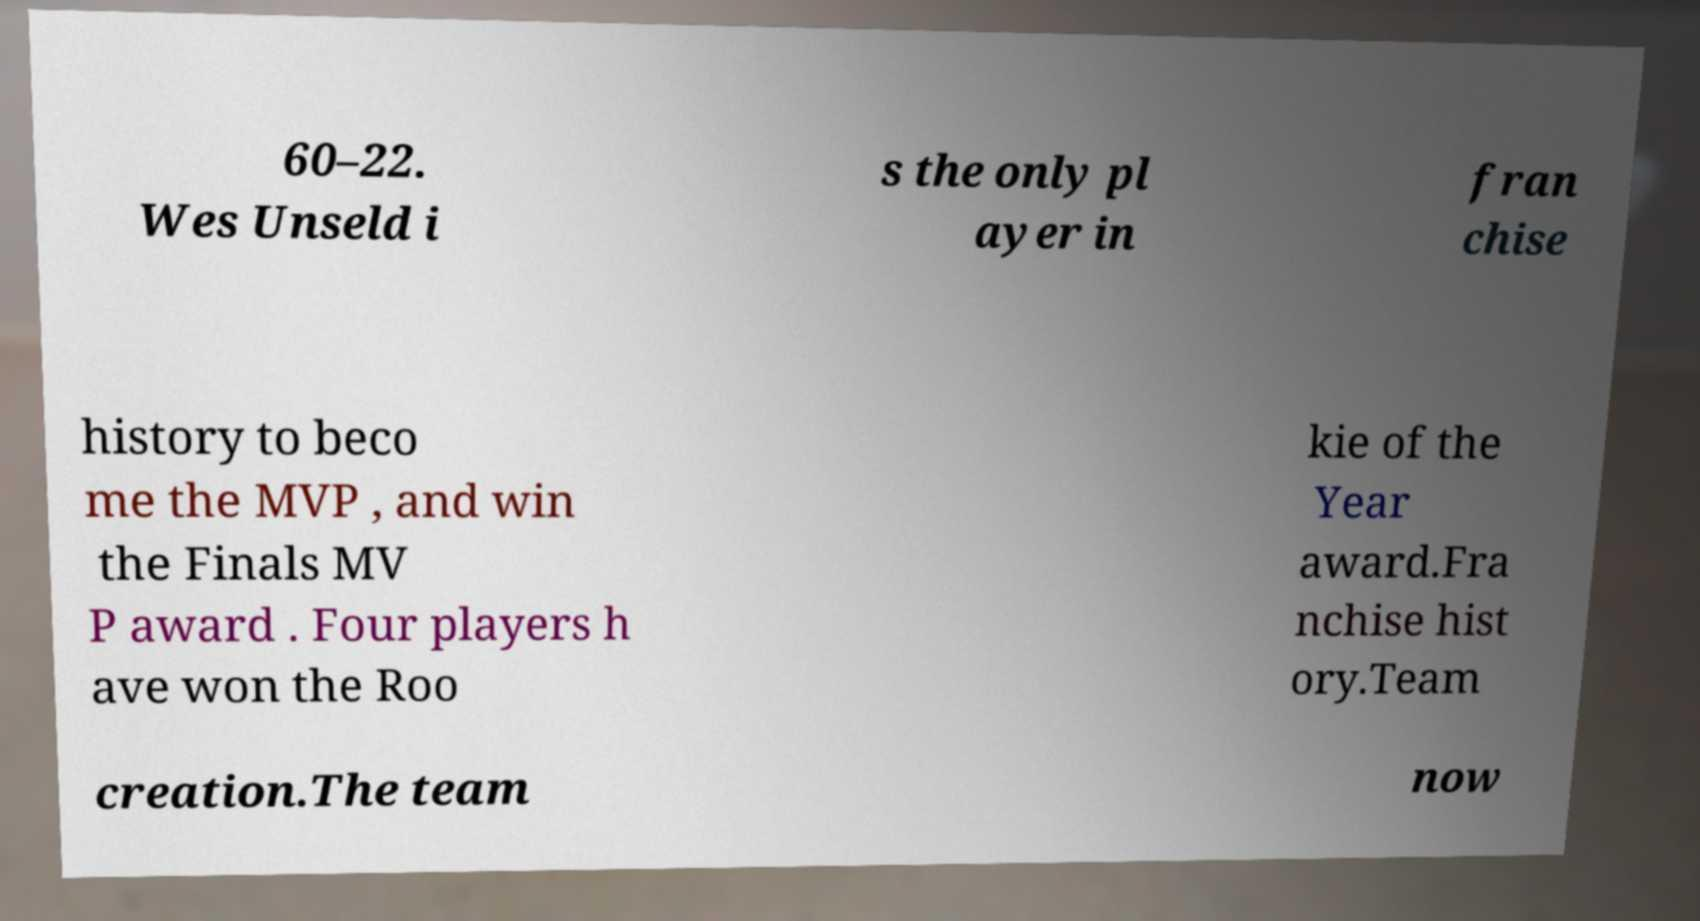What messages or text are displayed in this image? I need them in a readable, typed format. 60–22. Wes Unseld i s the only pl ayer in fran chise history to beco me the MVP , and win the Finals MV P award . Four players h ave won the Roo kie of the Year award.Fra nchise hist ory.Team creation.The team now 